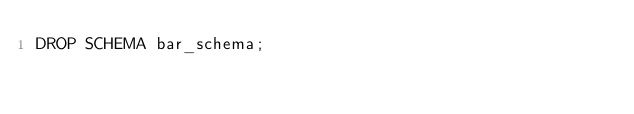<code> <loc_0><loc_0><loc_500><loc_500><_SQL_>DROP SCHEMA bar_schema;
</code> 